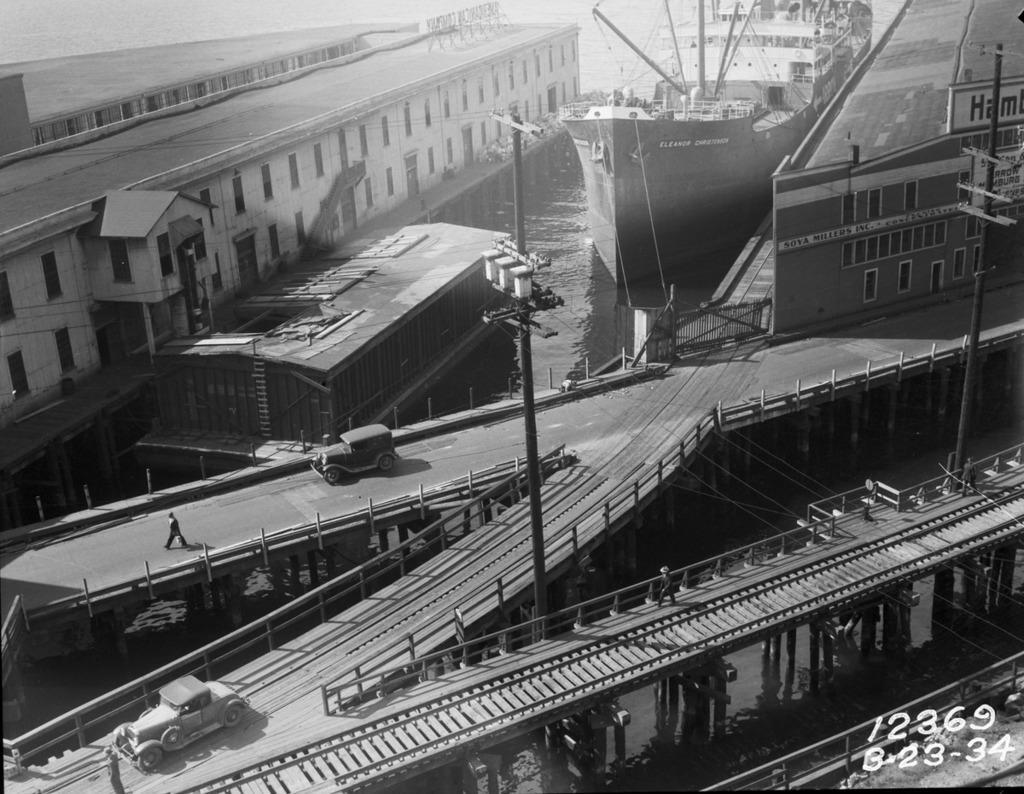Could you give a brief overview of what you see in this image? In this image there are roads on the bridges. There are vehicles moving on the roads. There is a person walking on the road. Beside the road there is water. There are ships and houseboats on the water. There are buildings on either sides of the image. There are electric poles in the image. In the bottom right there are numbers on the image. 